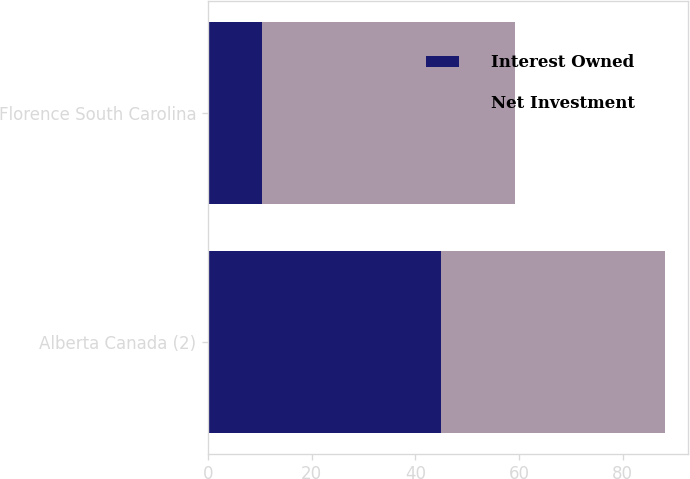<chart> <loc_0><loc_0><loc_500><loc_500><stacked_bar_chart><ecel><fcel>Alberta Canada (2)<fcel>Florence South Carolina<nl><fcel>Interest Owned<fcel>44.9<fcel>10.3<nl><fcel>Net Investment<fcel>43.37<fcel>49<nl></chart> 